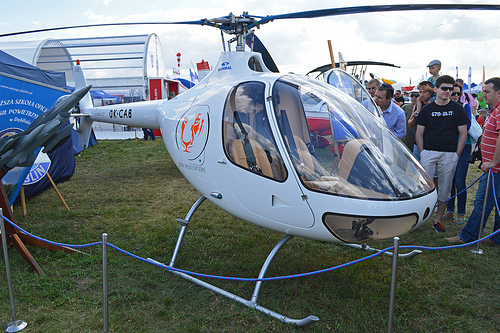<image>
Can you confirm if the helicopter is on the grass? Yes. Looking at the image, I can see the helicopter is positioned on top of the grass, with the grass providing support. Is the man in front of the helicopter? Yes. The man is positioned in front of the helicopter, appearing closer to the camera viewpoint. 